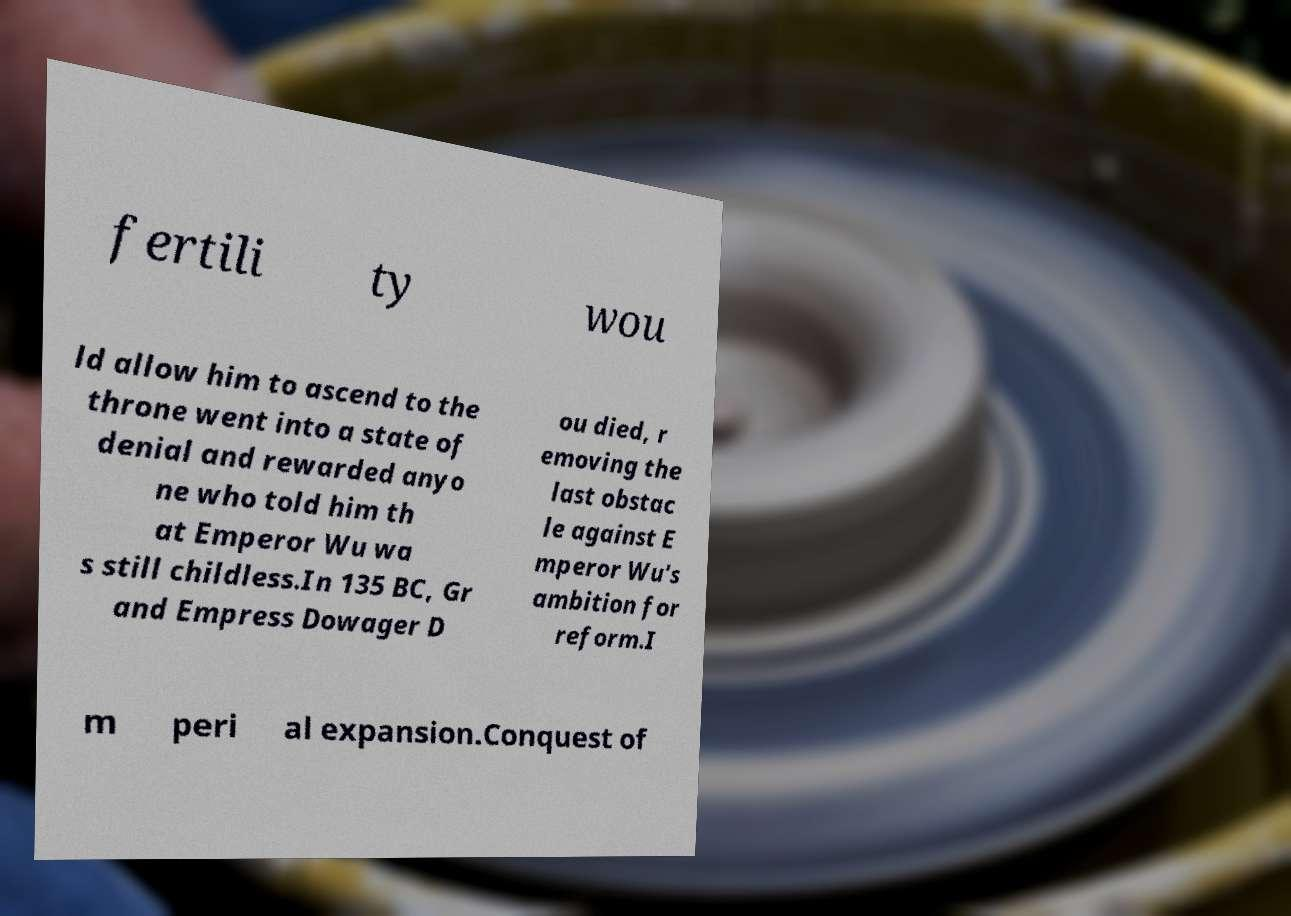I need the written content from this picture converted into text. Can you do that? fertili ty wou ld allow him to ascend to the throne went into a state of denial and rewarded anyo ne who told him th at Emperor Wu wa s still childless.In 135 BC, Gr and Empress Dowager D ou died, r emoving the last obstac le against E mperor Wu's ambition for reform.I m peri al expansion.Conquest of 